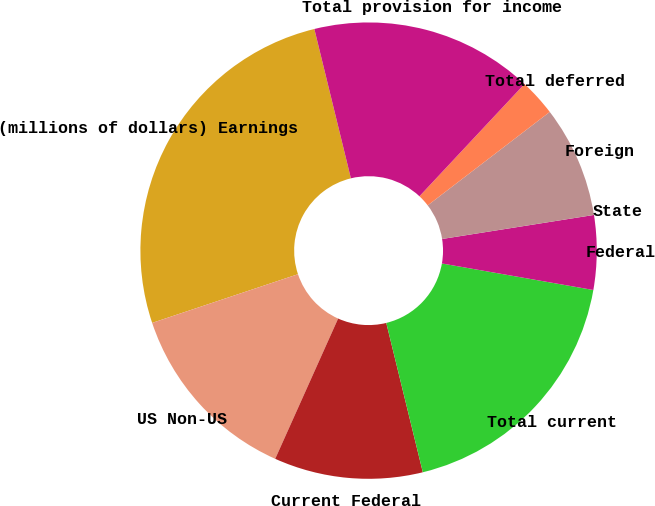<chart> <loc_0><loc_0><loc_500><loc_500><pie_chart><fcel>(millions of dollars) Earnings<fcel>US Non-US<fcel>Current Federal<fcel>Total current<fcel>Federal<fcel>State<fcel>Foreign<fcel>Total deferred<fcel>Total provision for income<nl><fcel>26.31%<fcel>13.16%<fcel>10.53%<fcel>18.42%<fcel>5.26%<fcel>0.0%<fcel>7.9%<fcel>2.63%<fcel>15.79%<nl></chart> 